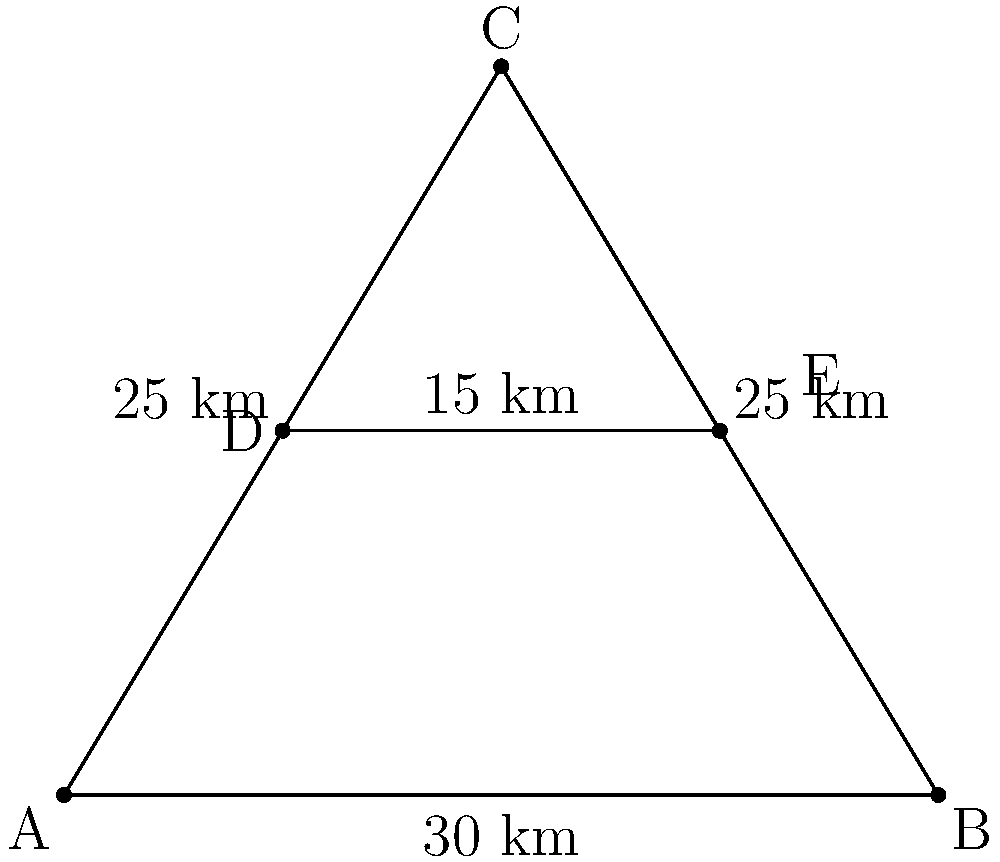In a triangular region ABC representing a county, two vaccination centers D and E are located on a line parallel to the base of the triangle. Given that AB = 30 km, AC = BC = 25 km, and DE = 15 km, what is the optimal distance of line DE from the base AB to maximize vaccination coverage area? To solve this problem, we need to follow these steps:

1) First, we need to find the height of the triangle. We can use the Pythagorean theorem:

   $$(25 \text{ km})^2 = (\frac{30}{2} \text{ km})^2 + h^2$$
   $$625 = 225 + h^2$$
   $$h^2 = 400$$
   $$h = 20 \text{ km}$$

2) The total area of the triangle is:

   $$A_{total} = \frac{1}{2} \times 30 \text{ km} \times 20 \text{ km} = 300 \text{ km}^2$$

3) Let's say the distance of DE from AB is x km. Then, the distance of DE from C is (20 - x) km.

4) The area covered by the two vaccination centers can be represented as:

   $$A_{covered} = 15x + \frac{1}{2} \times 30 \times (20-x) = 15x + 300 - 15x = 300 \text{ km}^2$$

5) This shows that regardless of where we place the line DE, the covered area remains constant at 300 km².

6) However, to maximize the efficiency of the vaccination centers, we should place them at the centroid of the triangle.

7) The centroid of a triangle divides each median in the ratio 2:1, counting from the vertex.

8) Therefore, the optimal distance of DE from AB is $\frac{2}{3}$ of the height of the triangle.

9) Optimal distance = $\frac{2}{3} \times 20 \text{ km} = 13.33 \text{ km}$
Answer: 13.33 km 